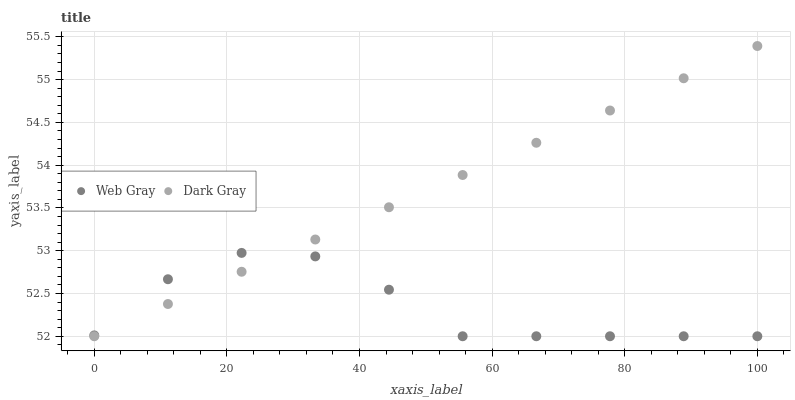Does Web Gray have the minimum area under the curve?
Answer yes or no. Yes. Does Dark Gray have the maximum area under the curve?
Answer yes or no. Yes. Does Web Gray have the maximum area under the curve?
Answer yes or no. No. Is Dark Gray the smoothest?
Answer yes or no. Yes. Is Web Gray the roughest?
Answer yes or no. Yes. Is Web Gray the smoothest?
Answer yes or no. No. Does Dark Gray have the lowest value?
Answer yes or no. Yes. Does Dark Gray have the highest value?
Answer yes or no. Yes. Does Web Gray have the highest value?
Answer yes or no. No. Does Dark Gray intersect Web Gray?
Answer yes or no. Yes. Is Dark Gray less than Web Gray?
Answer yes or no. No. Is Dark Gray greater than Web Gray?
Answer yes or no. No. 